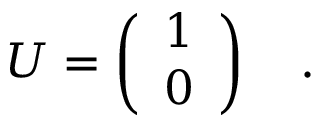Convert formula to latex. <formula><loc_0><loc_0><loc_500><loc_500>U = \left ( \begin{array} { c } { 1 } \\ { 0 } \end{array} \right ) \quad .</formula> 